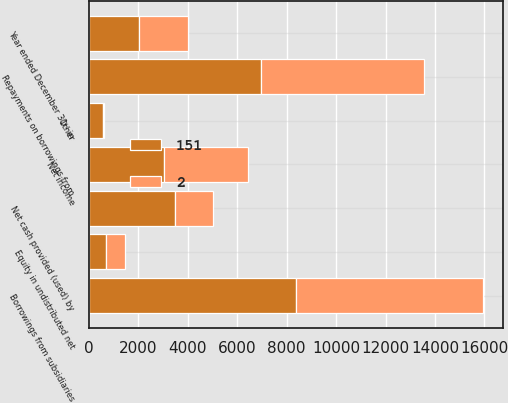<chart> <loc_0><loc_0><loc_500><loc_500><stacked_bar_chart><ecel><fcel>Year ended December 31 - in<fcel>Net income<fcel>Equity in undistributed net<fcel>Other<fcel>Net cash provided (used) by<fcel>Borrowings from subsidiaries<fcel>Repayments on borrowings from<nl><fcel>151<fcel>2012<fcel>3013<fcel>666<fcel>566<fcel>3482<fcel>8374<fcel>6943<nl><fcel>2<fcel>2010<fcel>3412<fcel>774<fcel>53<fcel>1535<fcel>7580<fcel>6596<nl></chart> 